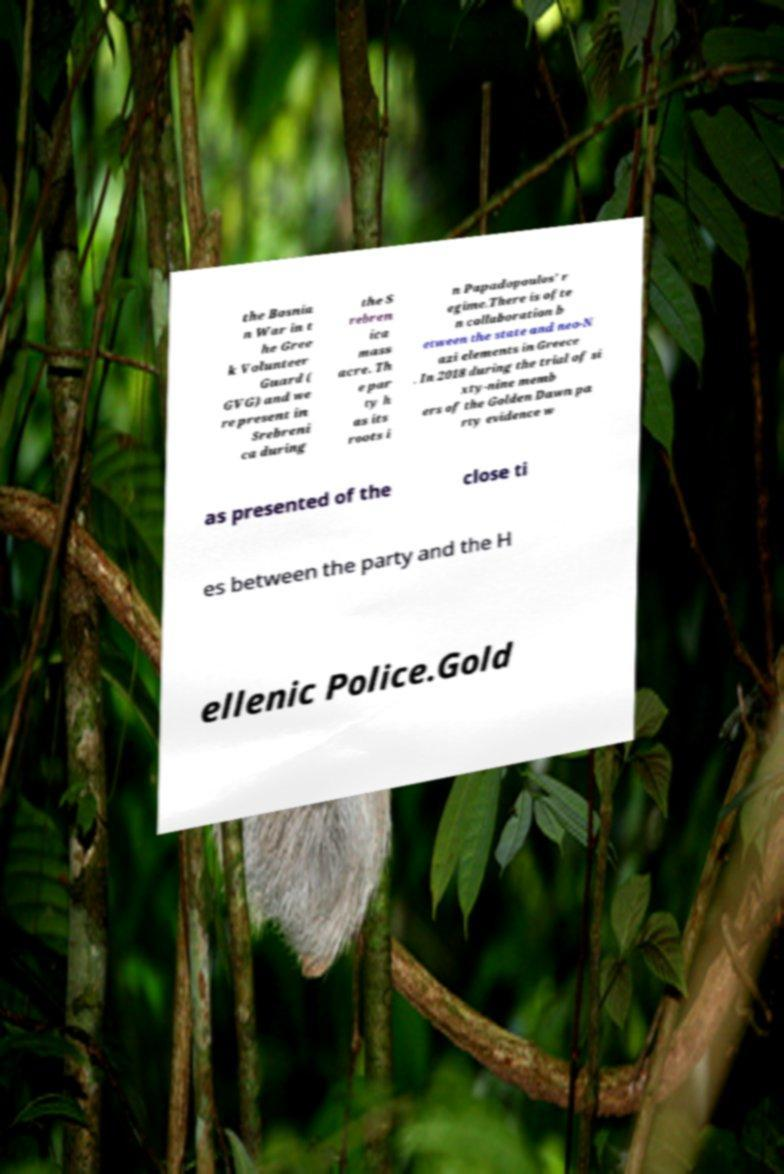Can you read and provide the text displayed in the image?This photo seems to have some interesting text. Can you extract and type it out for me? the Bosnia n War in t he Gree k Volunteer Guard ( GVG) and we re present in Srebreni ca during the S rebren ica mass acre. Th e par ty h as its roots i n Papadopoulos' r egime.There is ofte n collaboration b etween the state and neo-N azi elements in Greece . In 2018 during the trial of si xty-nine memb ers of the Golden Dawn pa rty evidence w as presented of the close ti es between the party and the H ellenic Police.Gold 